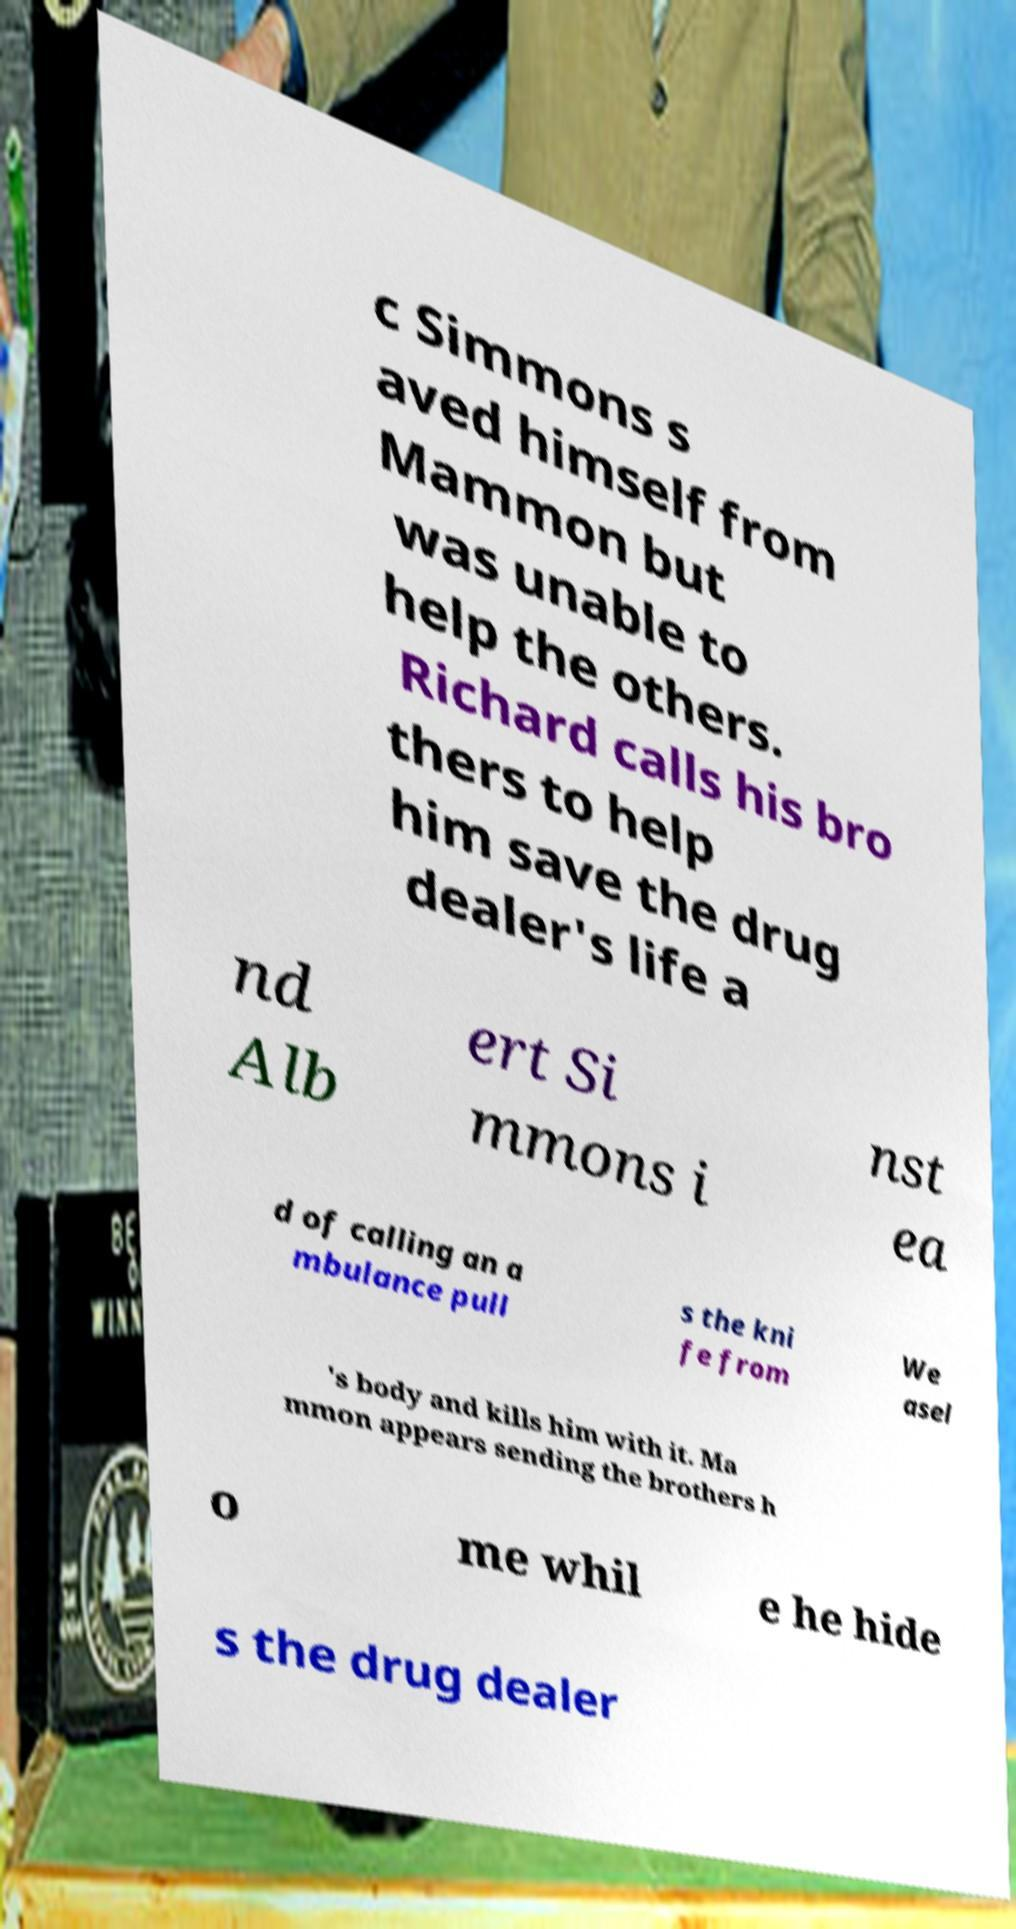For documentation purposes, I need the text within this image transcribed. Could you provide that? c Simmons s aved himself from Mammon but was unable to help the others. Richard calls his bro thers to help him save the drug dealer's life a nd Alb ert Si mmons i nst ea d of calling an a mbulance pull s the kni fe from We asel 's body and kills him with it. Ma mmon appears sending the brothers h o me whil e he hide s the drug dealer 